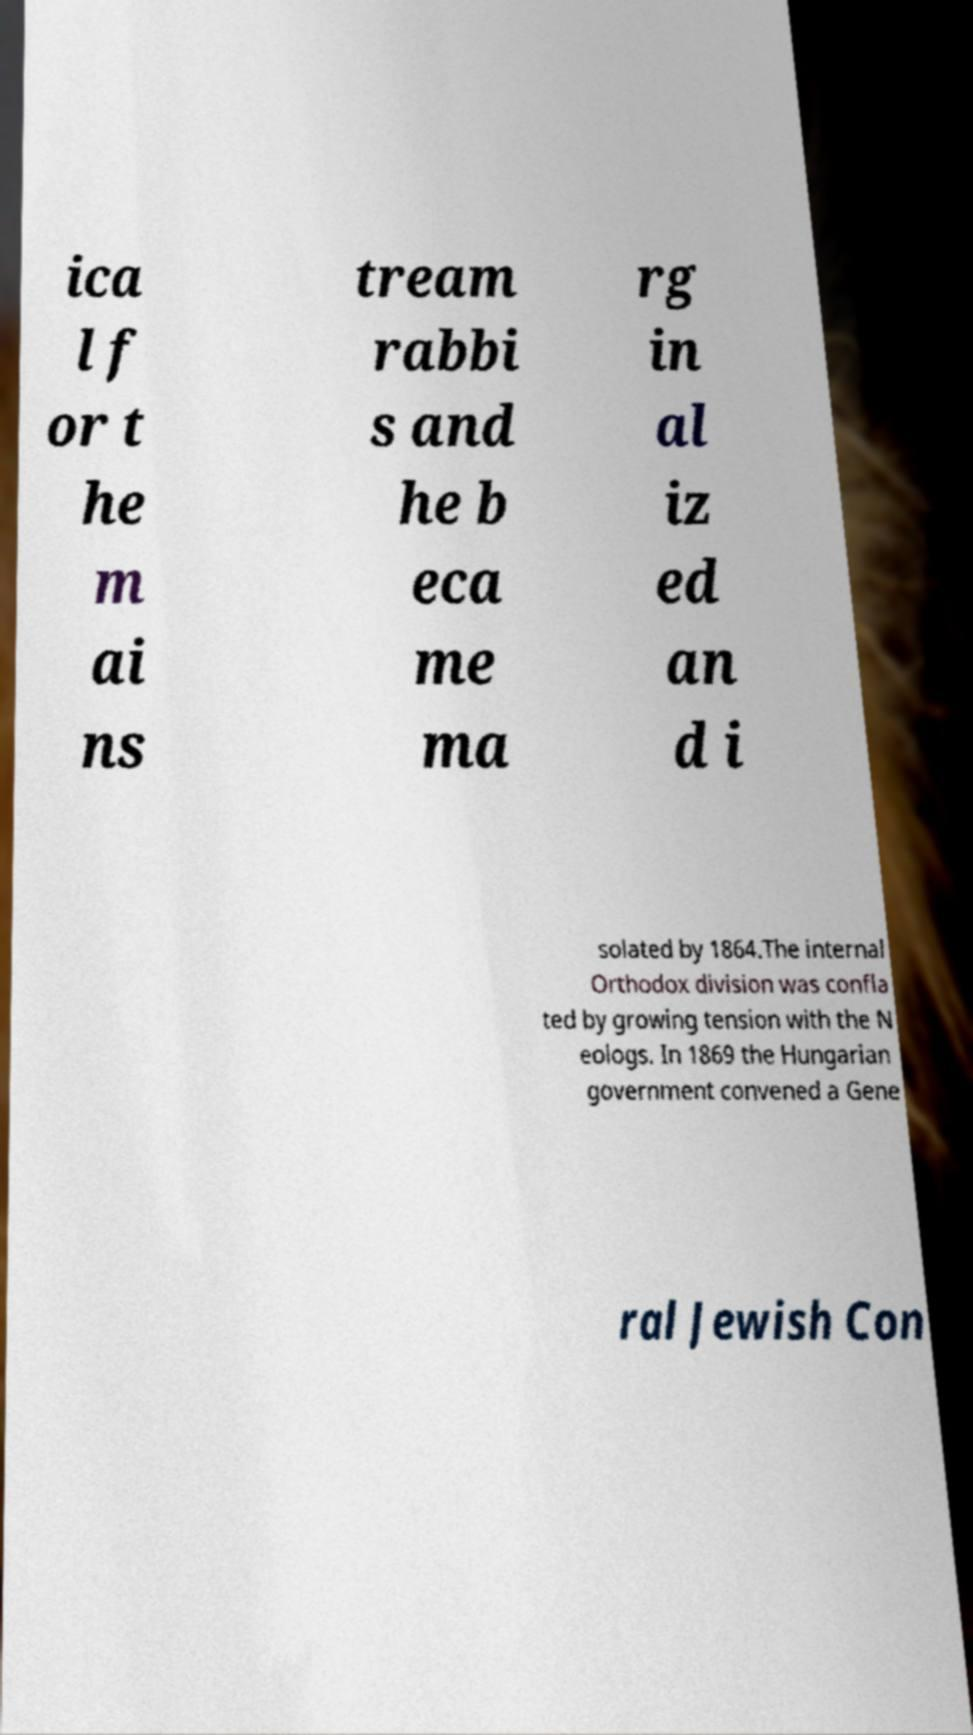Could you extract and type out the text from this image? ica l f or t he m ai ns tream rabbi s and he b eca me ma rg in al iz ed an d i solated by 1864.The internal Orthodox division was confla ted by growing tension with the N eologs. In 1869 the Hungarian government convened a Gene ral Jewish Con 